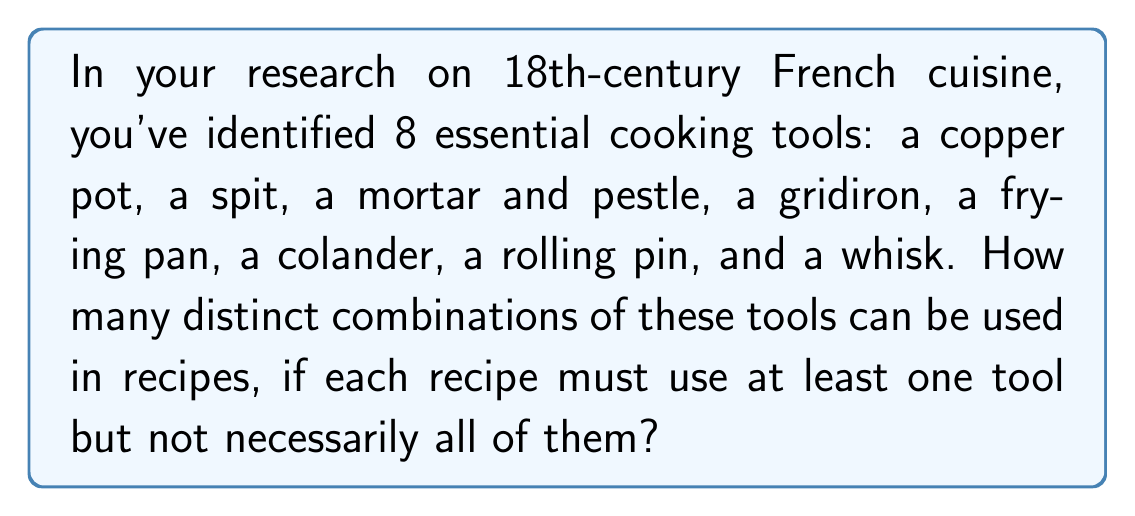Show me your answer to this math problem. To solve this problem, we need to use the concept of power sets, excluding the empty set. Here's the step-by-step approach:

1) First, we need to calculate the total number of possible combinations, including the empty set. This is given by $2^n$, where n is the number of items. In this case, $n = 8$.

   Total combinations = $2^8 = 256$

2) However, we need to exclude the empty set (the case where no tools are used) as the question states that each recipe must use at least one tool.

3) Therefore, we subtract 1 from our total:

   Distinct combinations = $2^8 - 1 = 256 - 1 = 255$

This can also be represented mathematically as:

$$ \sum_{k=1}^{8} \binom{8}{k} = 2^8 - 1 = 255 $$

Where $\binom{8}{k}$ represents the number of ways to choose $k$ tools from 8 tools.
Answer: 255 